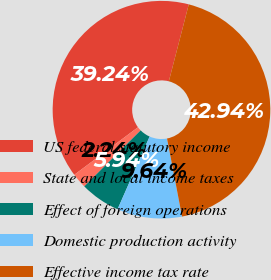Convert chart to OTSL. <chart><loc_0><loc_0><loc_500><loc_500><pie_chart><fcel>US federal statutory income<fcel>State and local income taxes<fcel>Effect of foreign operations<fcel>Domestic production activity<fcel>Effective income tax rate<nl><fcel>39.24%<fcel>2.24%<fcel>5.94%<fcel>9.64%<fcel>42.94%<nl></chart> 